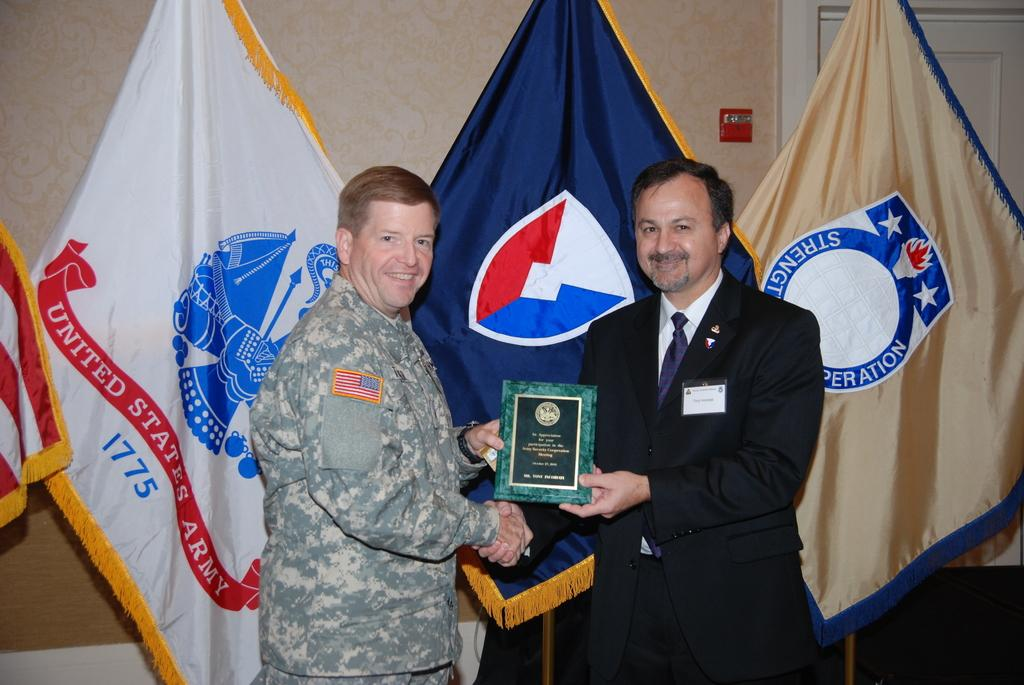<image>
Summarize the visual content of the image. A United States Army soldier is presented with an award during a ceremony. 